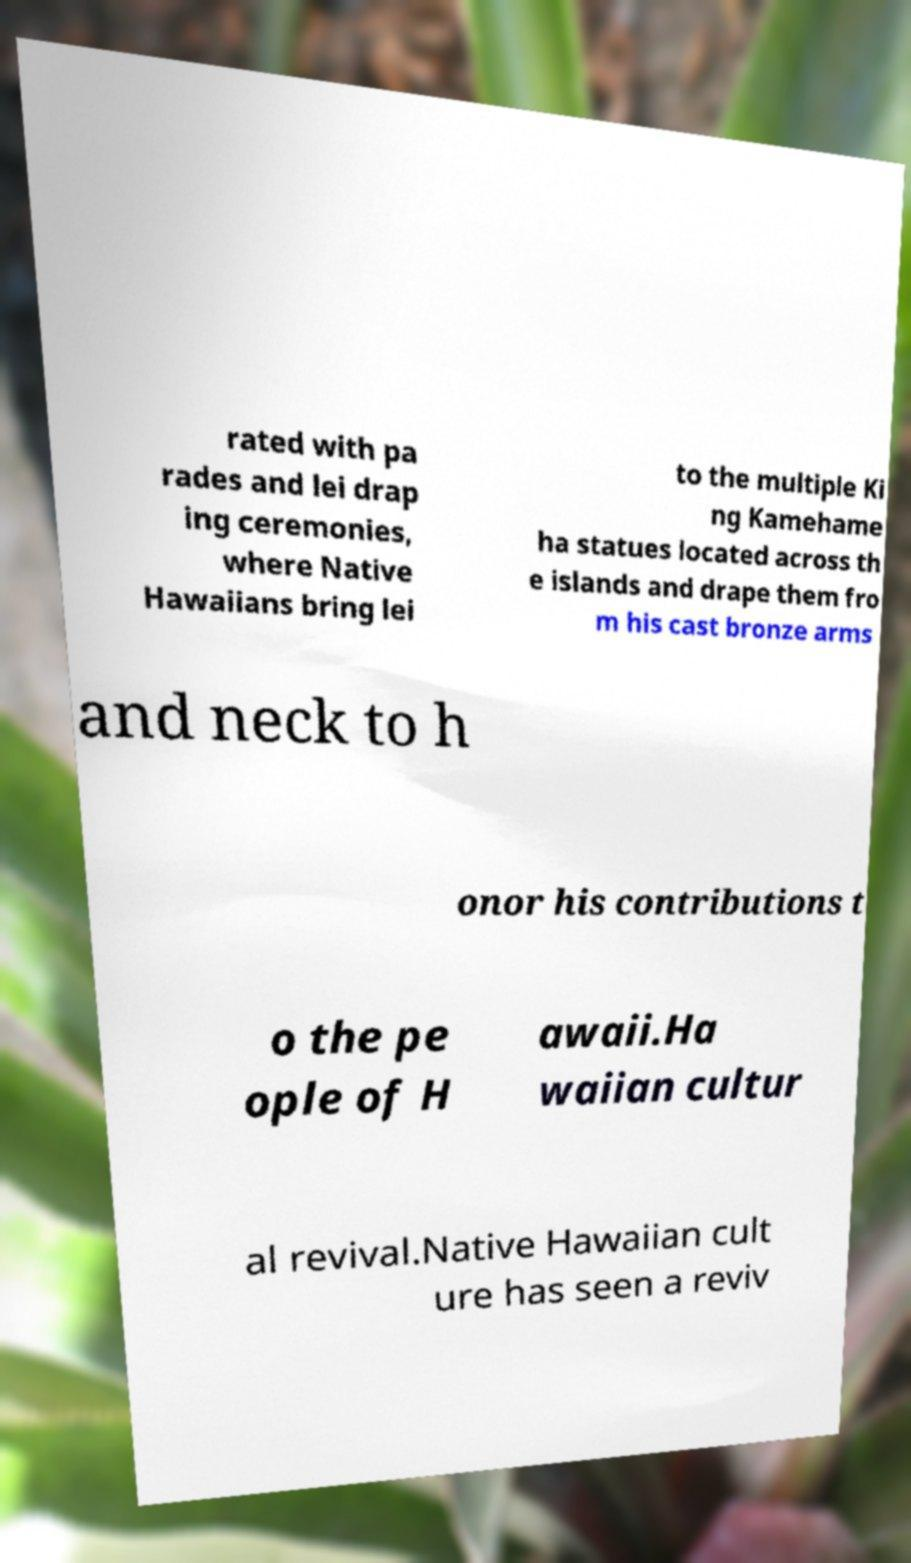Could you assist in decoding the text presented in this image and type it out clearly? rated with pa rades and lei drap ing ceremonies, where Native Hawaiians bring lei to the multiple Ki ng Kamehame ha statues located across th e islands and drape them fro m his cast bronze arms and neck to h onor his contributions t o the pe ople of H awaii.Ha waiian cultur al revival.Native Hawaiian cult ure has seen a reviv 